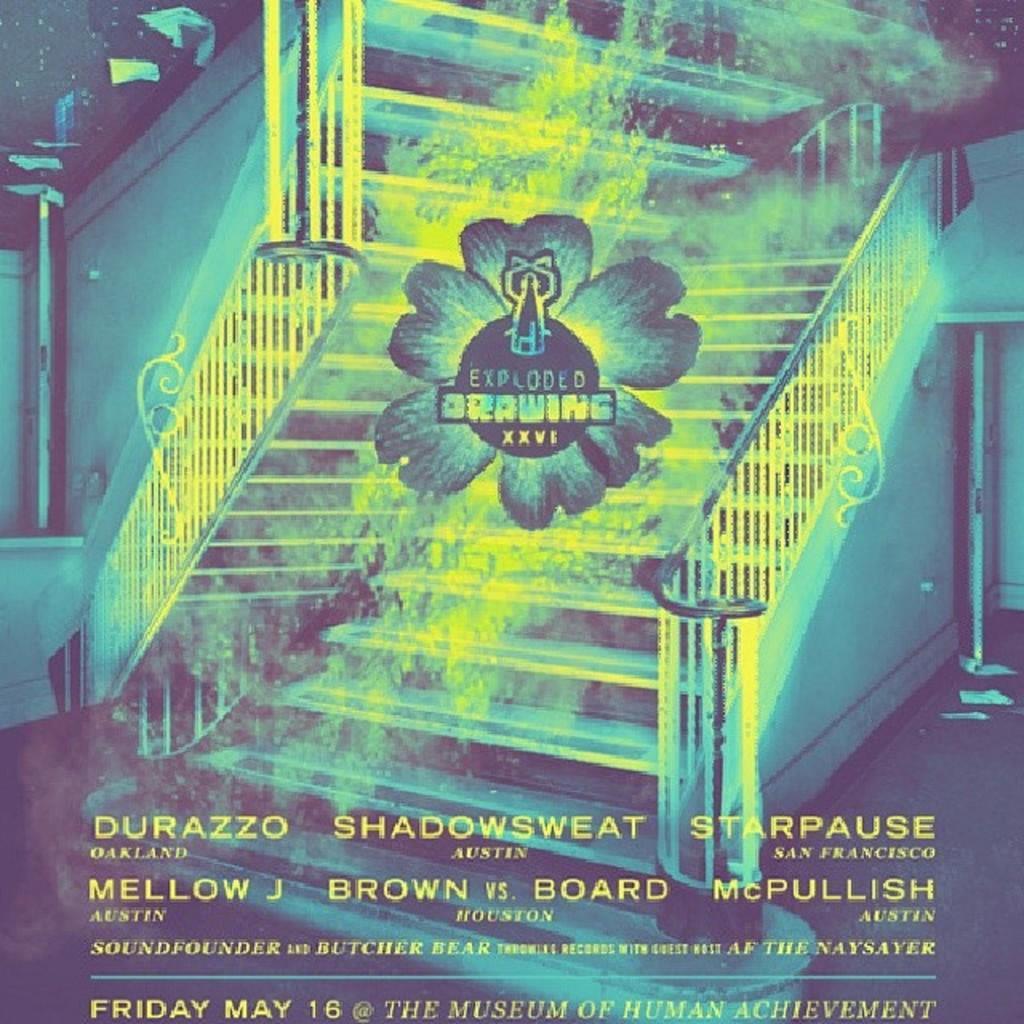In one or two sentences, can you explain what this image depicts? In this picture I can see a poster with some text at the bottom of the picture and I can see stairs and looks like a logo in the middle of the picture with some text. 